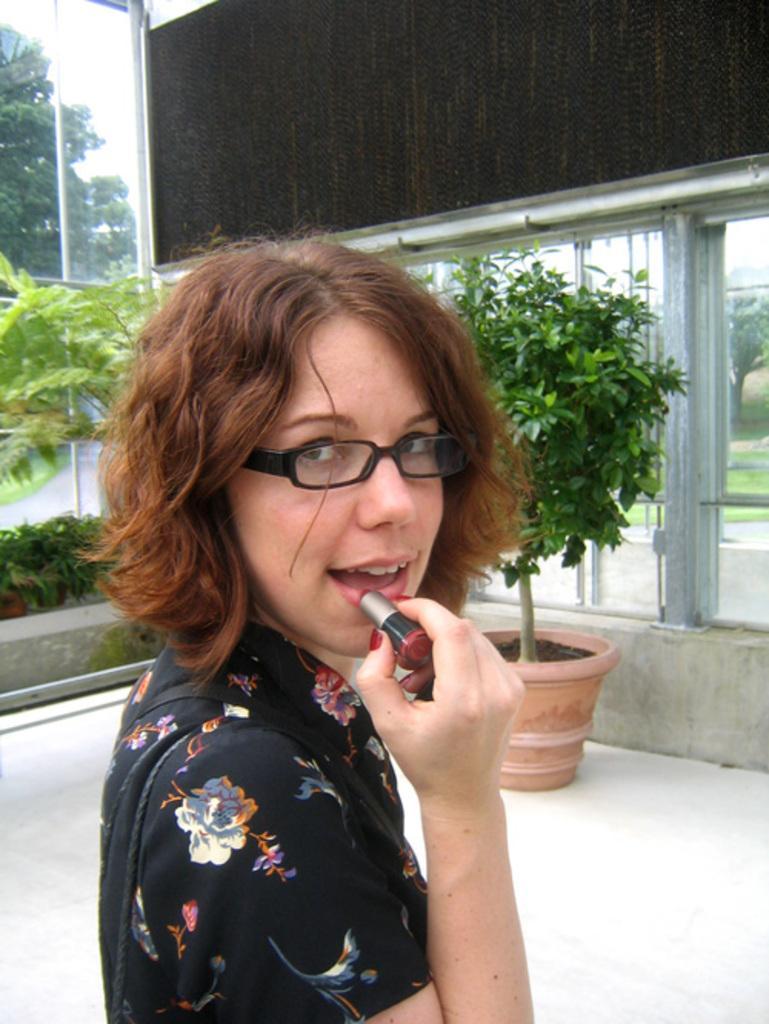How would you summarize this image in a sentence or two? In this image I can see the person wearing the black color dress and holding the lipstick. In the background I can see the flower pots, black color board and the road. I can also see the trees and the sky in the back. 